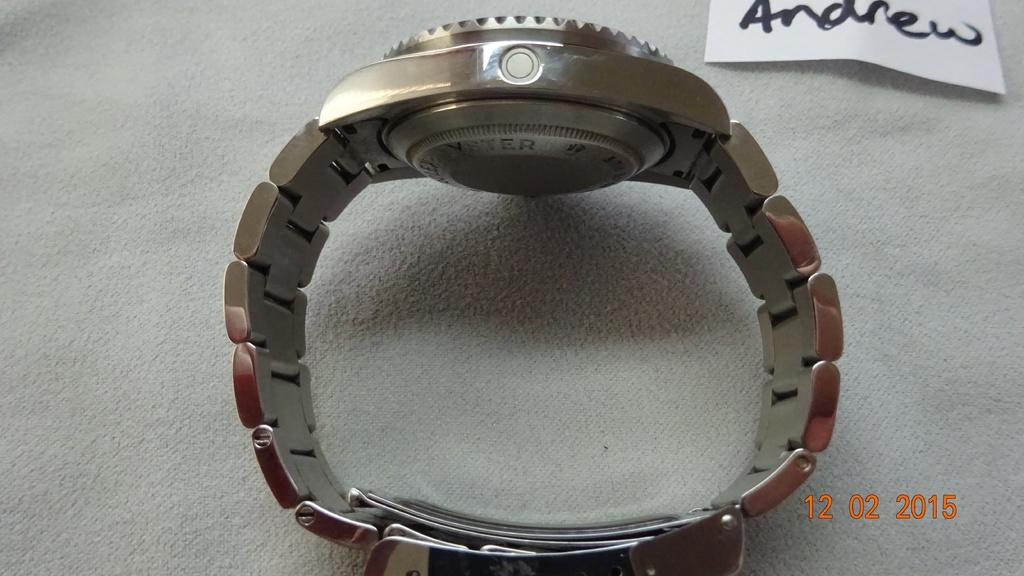<image>
Render a clear and concise summary of the photo. A metal banded watch on display meant for Andrew. 